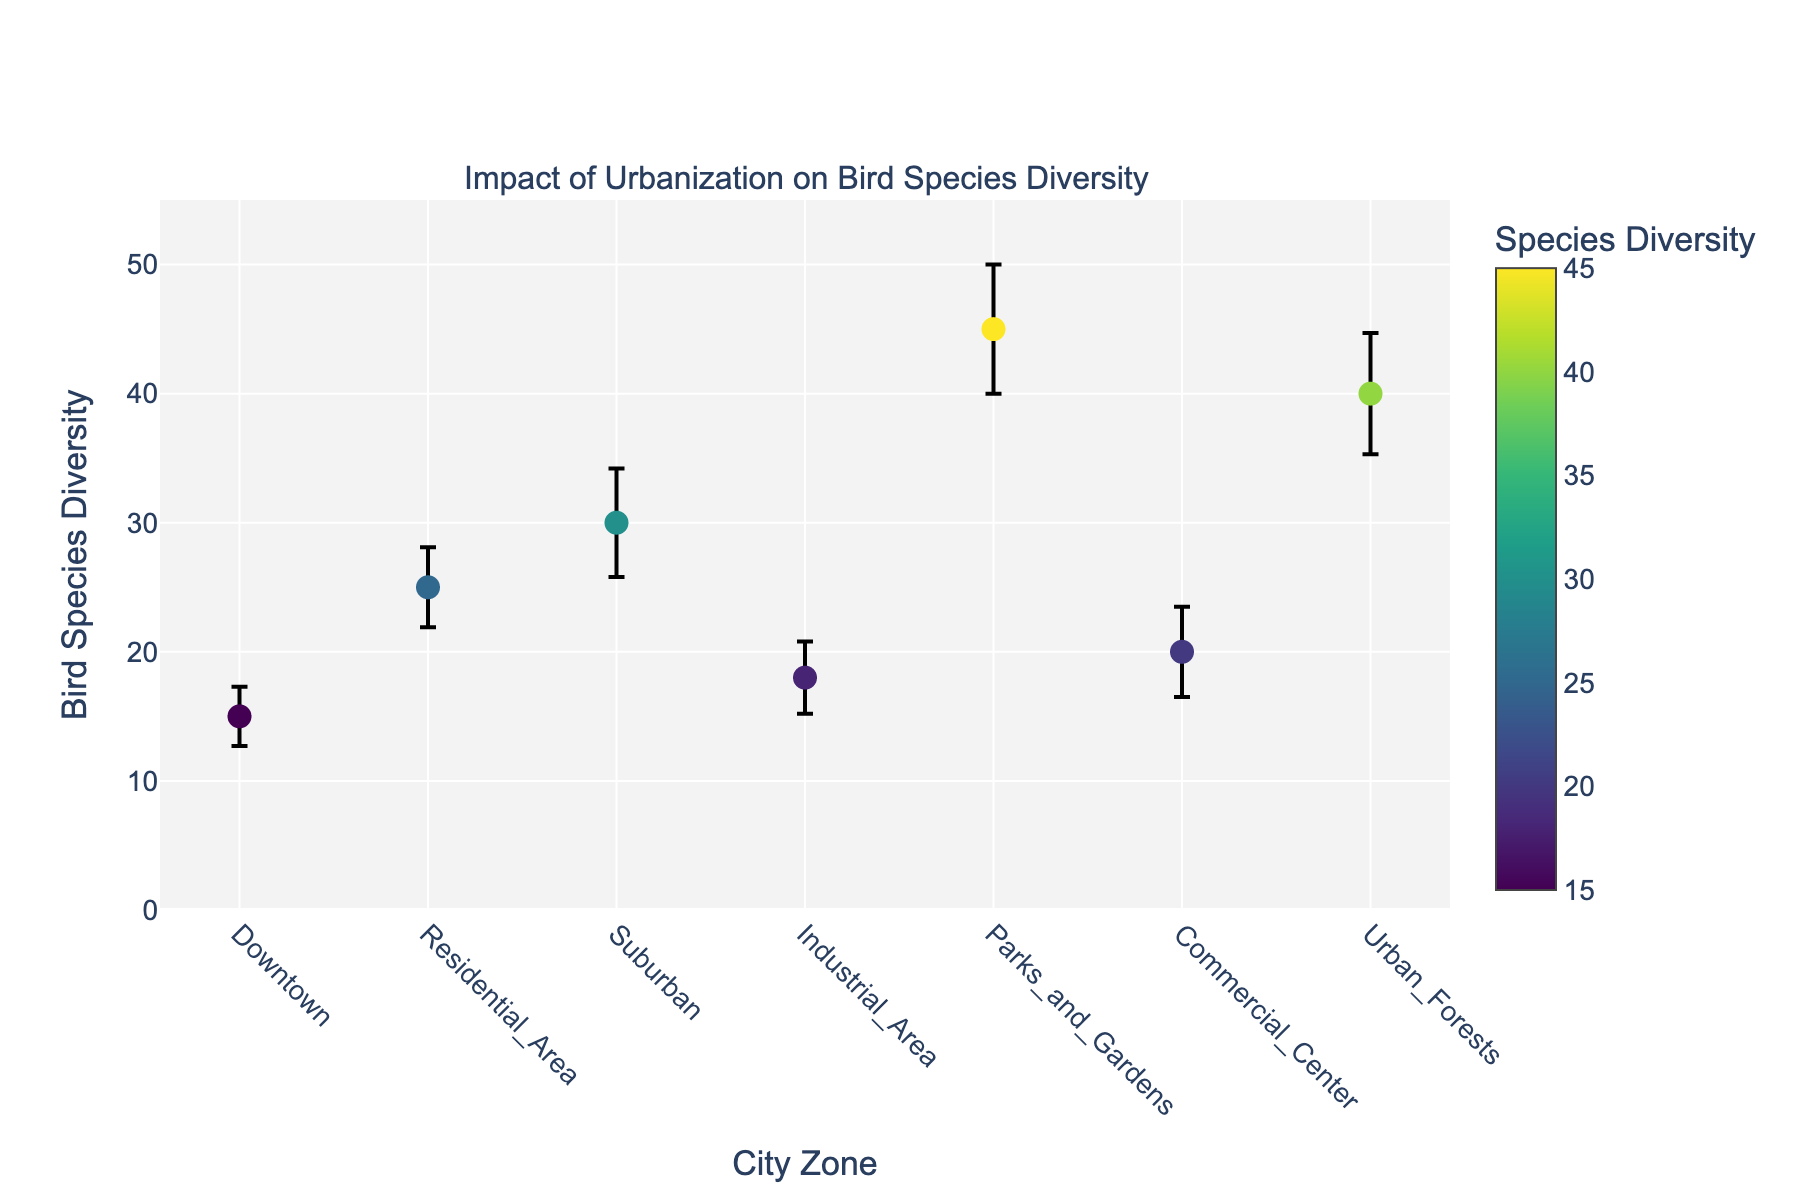What is the title of the plot? The title of the plot is given at the top and reads "Impact of Urbanization on Bird Species Diversity."
Answer: Impact of Urbanization on Bird Species Diversity How many city zones are displayed on the x-axis? There are seven distinct city zones displayed along the x-axis: Downtown, Residential Area, Suburban, Industrial Area, Parks and Gardens, Commercial Center, and Urban Forests.
Answer: Seven Which city zone has the highest bird species diversity? By looking at the y-axis values for bird species diversity, the city zone Parks and Gardens shows the highest value.
Answer: Parks and Gardens What is the bird species diversity in Commercial Center? The value of bird species diversity for the Commercial Center can be read directly from the corresponding y-coordinate, which is 20.
Answer: 20 What is the bird species diversity in Residential Area? The value of bird species diversity for the Residential Area can be read directly from the corresponding y-coordinate, which is 25.
Answer: 25 Which city zone has the lowest bird species diversity? By looking at the y-axis values for bird species diversity, the city zone Downtown shows the lowest value.
Answer: Downtown What is the range of bird species diversity values shown in the plot? The minimum bird species diversity value is 15 (Downtown) and the maximum is 45 (Parks and Gardens), making the range 45 - 15 = 30.
Answer: 30 How does the bird species diversity in Suburban compare to Downtown? The bird species diversity in Suburban is higher than in Downtown. Suburban has 30 while Downtown has 15.
Answer: Higher What is the difference in bird species diversity between Urban Forests and Industrial Area? The bird species diversity in Urban Forests is 40 and in Industrial Area is 18. The difference is 40 - 18 = 22.
Answer: 22 What does the color scale in the plot represent? The color scale displayed on the figure represents the bird species diversity, with different colors indicating different levels of biodiversity.
Answer: Bird species diversity Considering error bars, which city zone has the greatest uncertainty in bird species diversity measurements? By observing the length of the error bars, Parks and Gardens have the greatest uncertainty, denoted by the lengthiest error bar of 5.
Answer: Parks and Gardens 